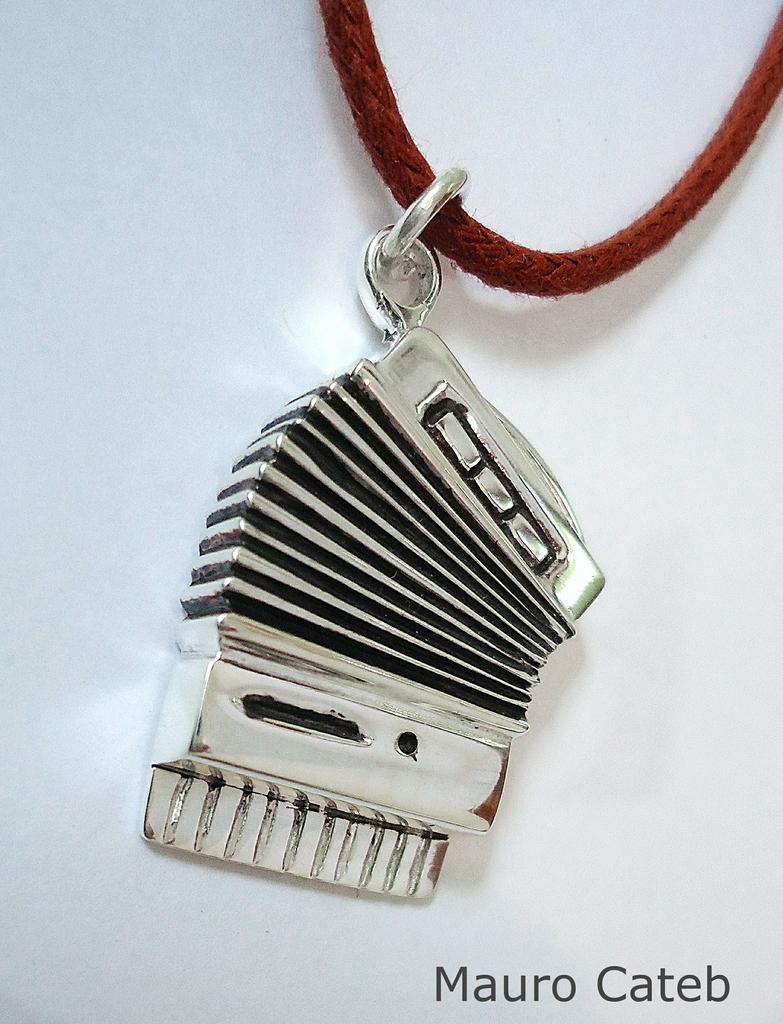What is hanging from a thread in the image? There is an object on a thread in the image. What can be found at the bottom of the image? There is text at the bottom of the image. What is visible in the background of the image? There is a wall in the background of the image. What type of picture is being used to surprise the government in the image? There is no picture or mention of a government in the image; it only features an object hanging from a thread, text at the bottom, and a wall in the background. 